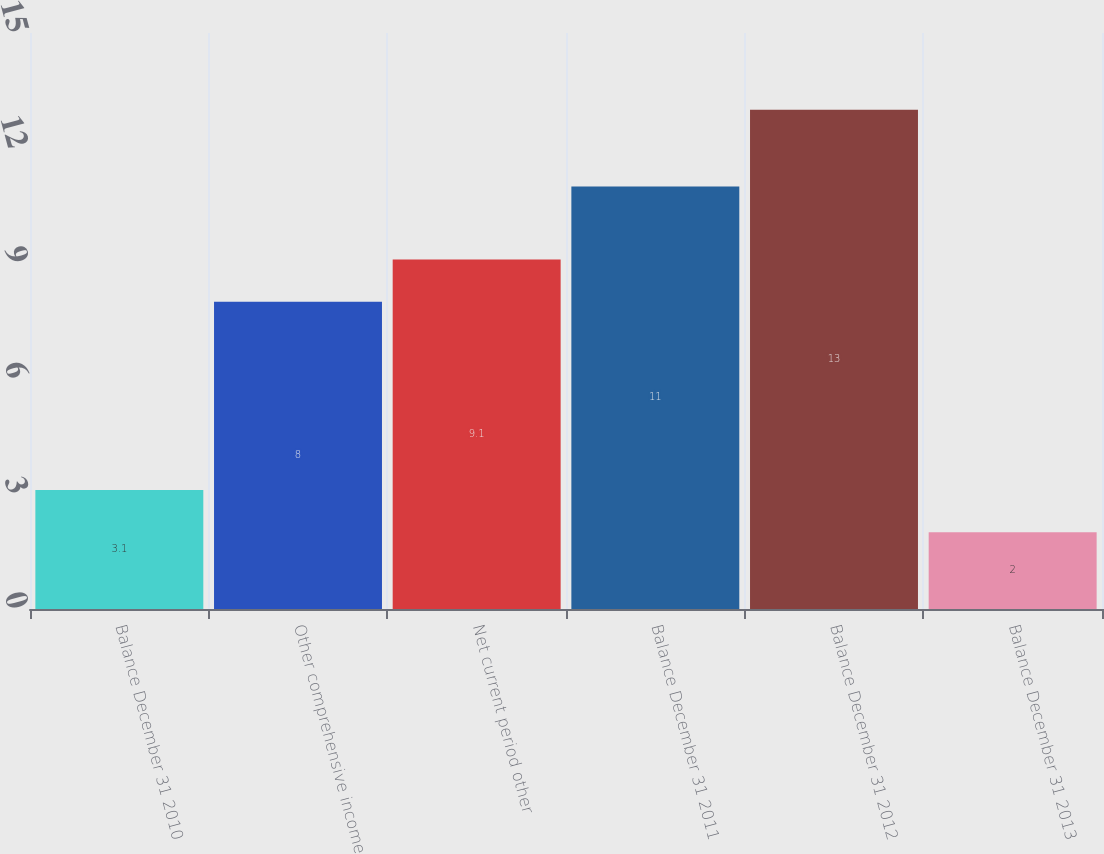Convert chart to OTSL. <chart><loc_0><loc_0><loc_500><loc_500><bar_chart><fcel>Balance December 31 2010<fcel>Other comprehensive income<fcel>Net current period other<fcel>Balance December 31 2011<fcel>Balance December 31 2012<fcel>Balance December 31 2013<nl><fcel>3.1<fcel>8<fcel>9.1<fcel>11<fcel>13<fcel>2<nl></chart> 